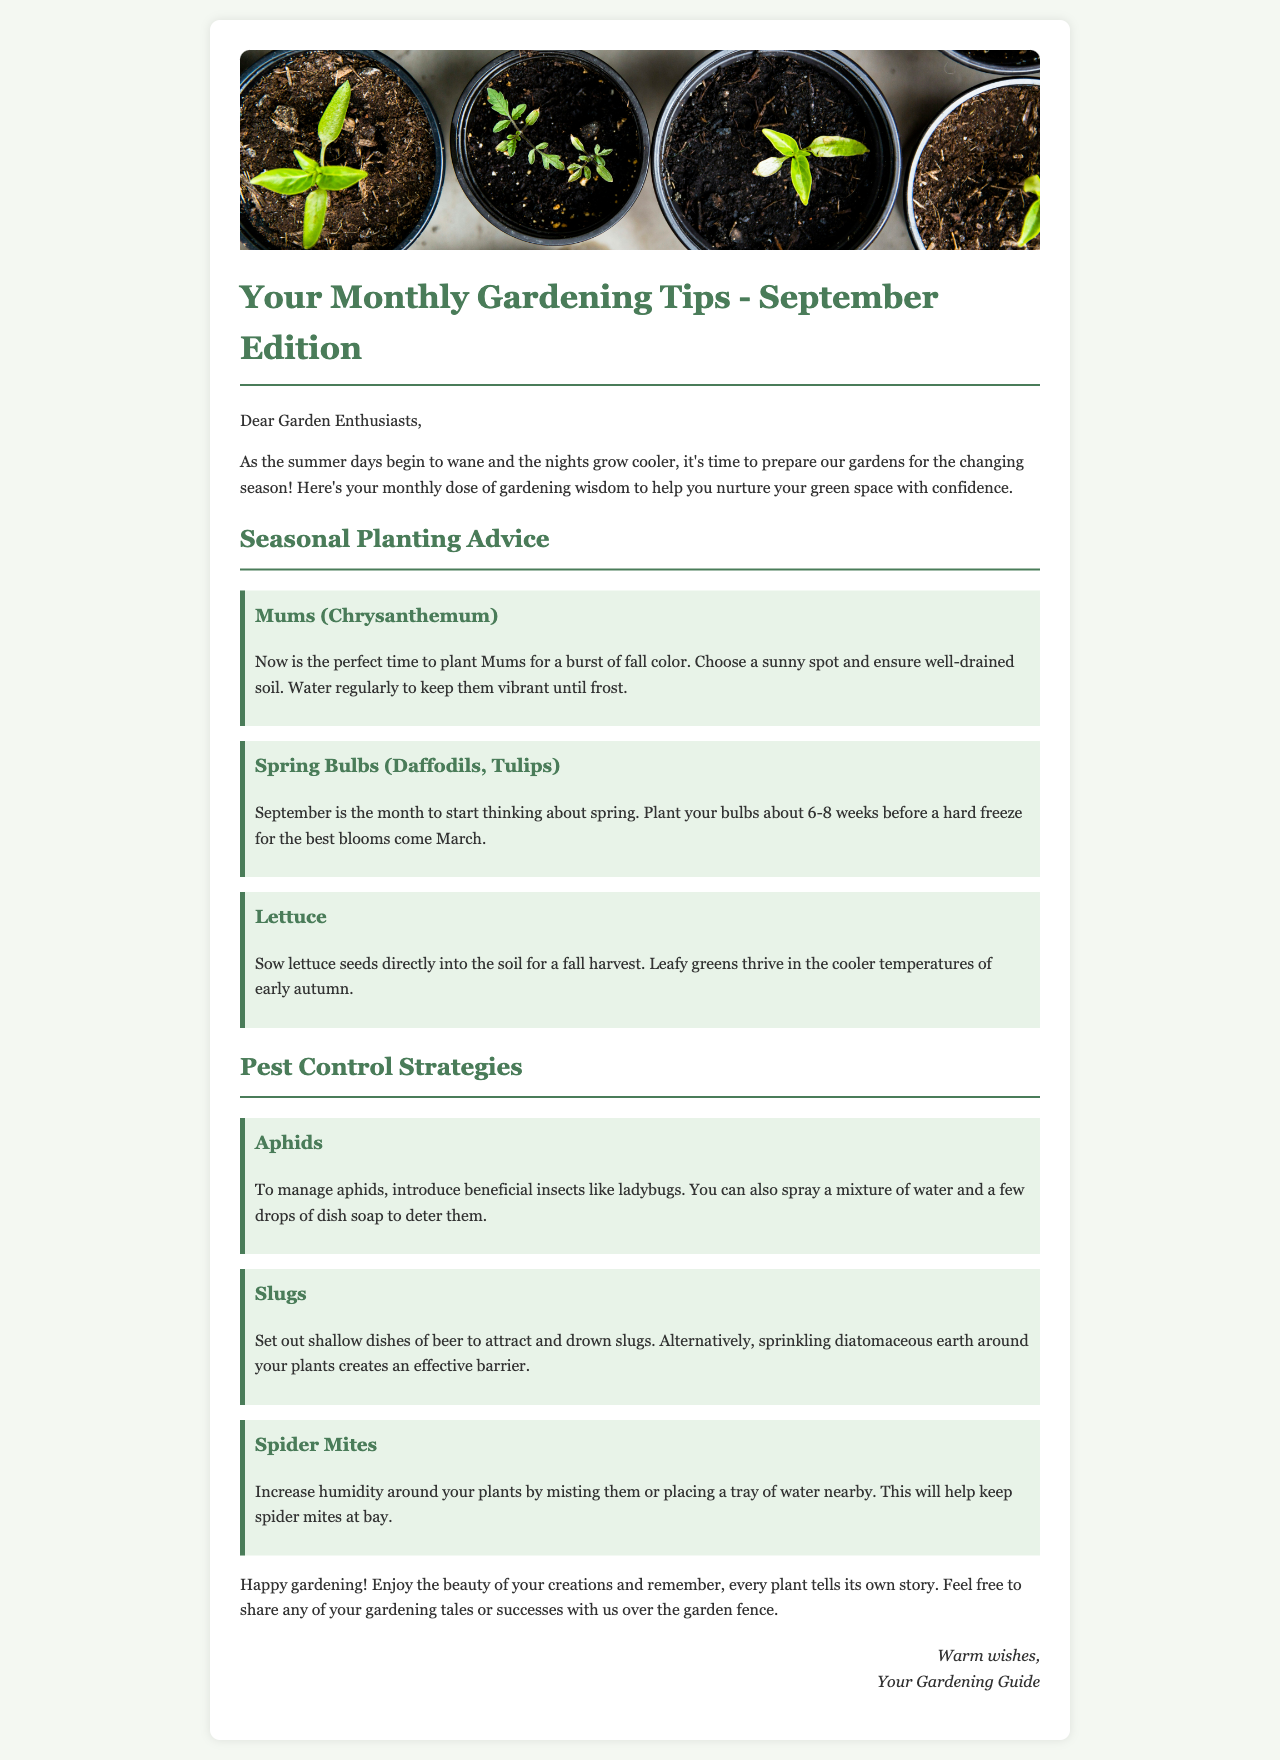what is the title of the newsletter? The title of the newsletter is stated at the top of the document.
Answer: Your Monthly Gardening Tips - September Edition what is the first plant mentioned in the seasonal planting advice? The first plant mentioned is highlighted in the section dedicated to seasonal planting advice.
Answer: Mums (Chrysanthemum) how should you manage aphids? The document provides a specific method for managing aphids in the pest control strategies section.
Answer: Introduce beneficial insects like ladybugs how often should Mums be watered? The advice given for Mums in the planting section includes a watering recommendation.
Answer: Regularly what is the suggested planting period for spring bulbs? The planting period for spring bulbs is mentioned in relation to a specific condition.
Answer: 6-8 weeks before a hard freeze what is one strategy to deter slugs? The document includes specific methods to manage slugs in the pest control strategies section.
Answer: Set out shallow dishes of beer how can you help prevent spider mites? The document discusses increasing humidity as a strategy related to spider mites.
Answer: Increase humidity around your plants what is the overall tone of the newsletter? The tone of the newsletter can be inferred from the closing remark and language used throughout.
Answer: Warm and encouraging 